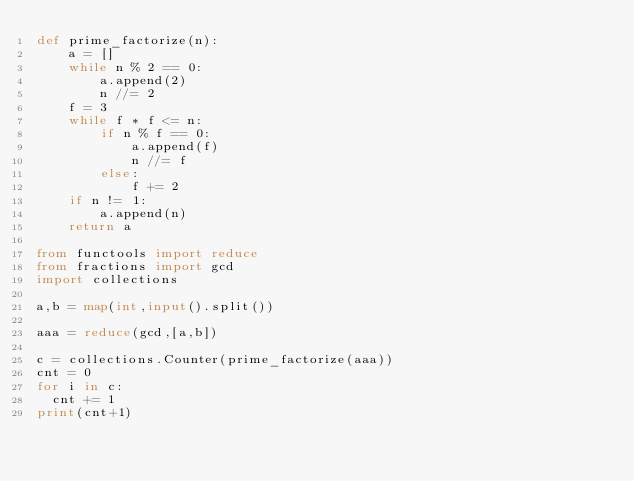Convert code to text. <code><loc_0><loc_0><loc_500><loc_500><_Python_>def prime_factorize(n):
    a = []
    while n % 2 == 0:
        a.append(2)
        n //= 2
    f = 3
    while f * f <= n:
        if n % f == 0:
            a.append(f)
            n //= f
        else:
            f += 2
    if n != 1:
        a.append(n)
    return a

from functools import reduce
from fractions import gcd
import collections

a,b = map(int,input().split())

aaa = reduce(gcd,[a,b])

c = collections.Counter(prime_factorize(aaa))
cnt = 0
for i in c:
  cnt += 1
print(cnt+1)</code> 